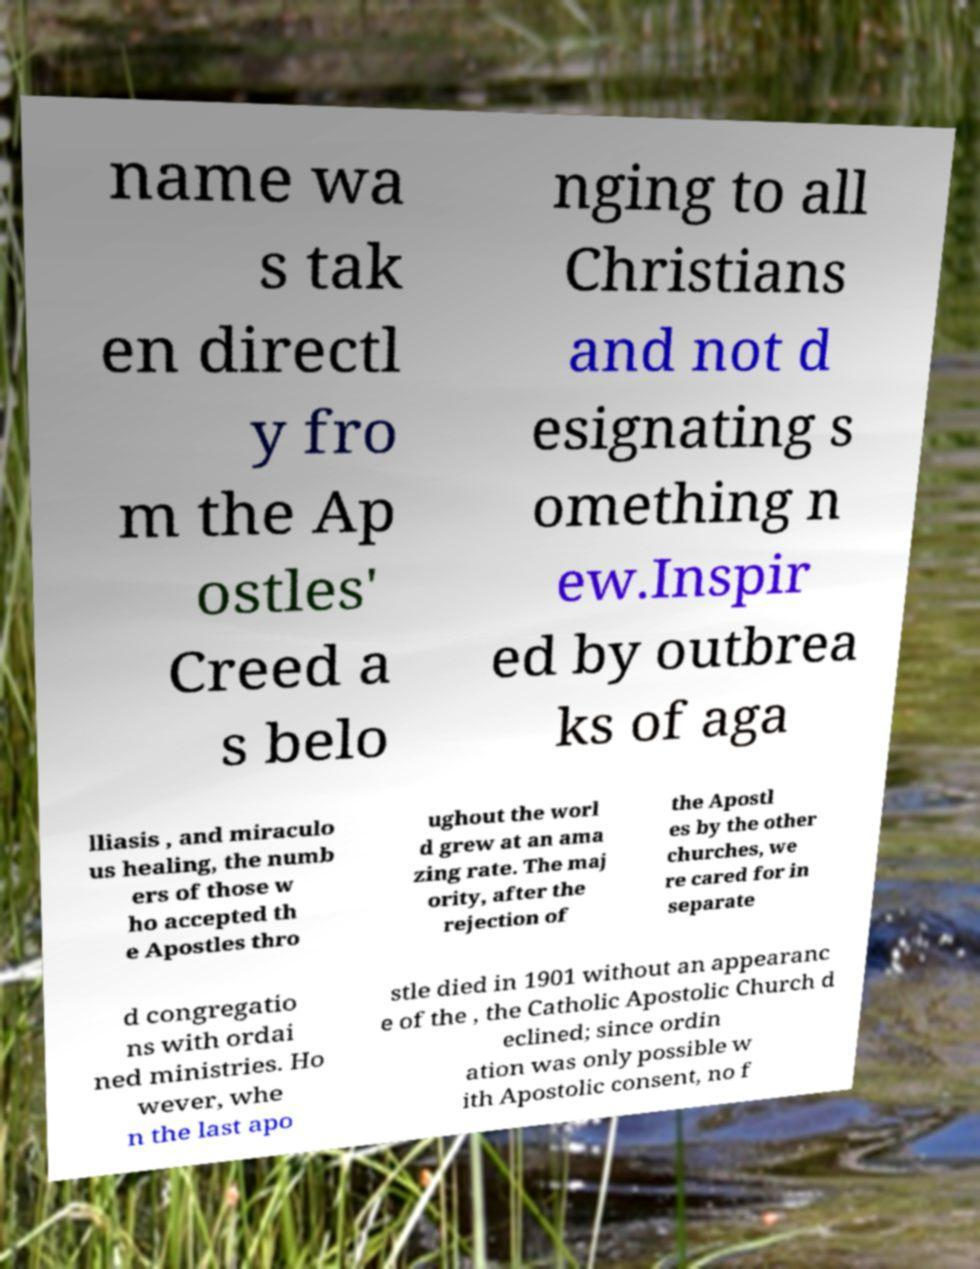Could you assist in decoding the text presented in this image and type it out clearly? name wa s tak en directl y fro m the Ap ostles' Creed a s belo nging to all Christians and not d esignating s omething n ew.Inspir ed by outbrea ks of aga lliasis , and miraculo us healing, the numb ers of those w ho accepted th e Apostles thro ughout the worl d grew at an ama zing rate. The maj ority, after the rejection of the Apostl es by the other churches, we re cared for in separate d congregatio ns with ordai ned ministries. Ho wever, whe n the last apo stle died in 1901 without an appearanc e of the , the Catholic Apostolic Church d eclined; since ordin ation was only possible w ith Apostolic consent, no f 